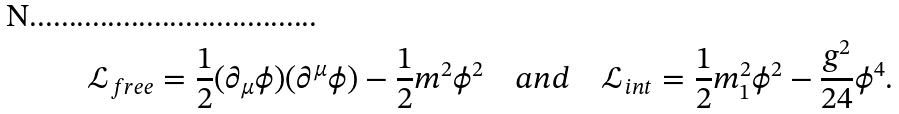<formula> <loc_0><loc_0><loc_500><loc_500>\mathcal { L } _ { f r e e } = \frac { 1 } { 2 } ( \partial _ { \mu } \phi ) ( \partial ^ { \mu } \phi ) - \frac { 1 } { 2 } m ^ { 2 } \phi ^ { 2 } \quad a n d \quad \mathcal { L } _ { i n t } = \frac { 1 } { 2 } m _ { 1 } ^ { 2 } \phi ^ { 2 } - \frac { g ^ { 2 } } { 2 4 } \phi ^ { 4 } .</formula> 